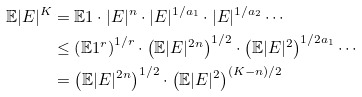<formula> <loc_0><loc_0><loc_500><loc_500>\mathbb { E } | E | ^ { K } & = \mathbb { E } 1 \cdot | E | ^ { n } \cdot | E | ^ { 1 / a _ { 1 } } \cdot | E | ^ { 1 / a _ { 2 } } \cdots \\ & \leq \left ( \mathbb { E } 1 ^ { r } \right ) ^ { 1 / r } \cdot \left ( \mathbb { E } | E | ^ { 2 n } \right ) ^ { 1 / 2 } \cdot \left ( \mathbb { E } | E | ^ { 2 } \right ) ^ { 1 / 2 a _ { 1 } } \cdots \\ & = \left ( \mathbb { E } | E | ^ { 2 n } \right ) ^ { 1 / 2 } \cdot \left ( \mathbb { E } | E | ^ { 2 } \right ) ^ { ( K - n ) / 2 }</formula> 